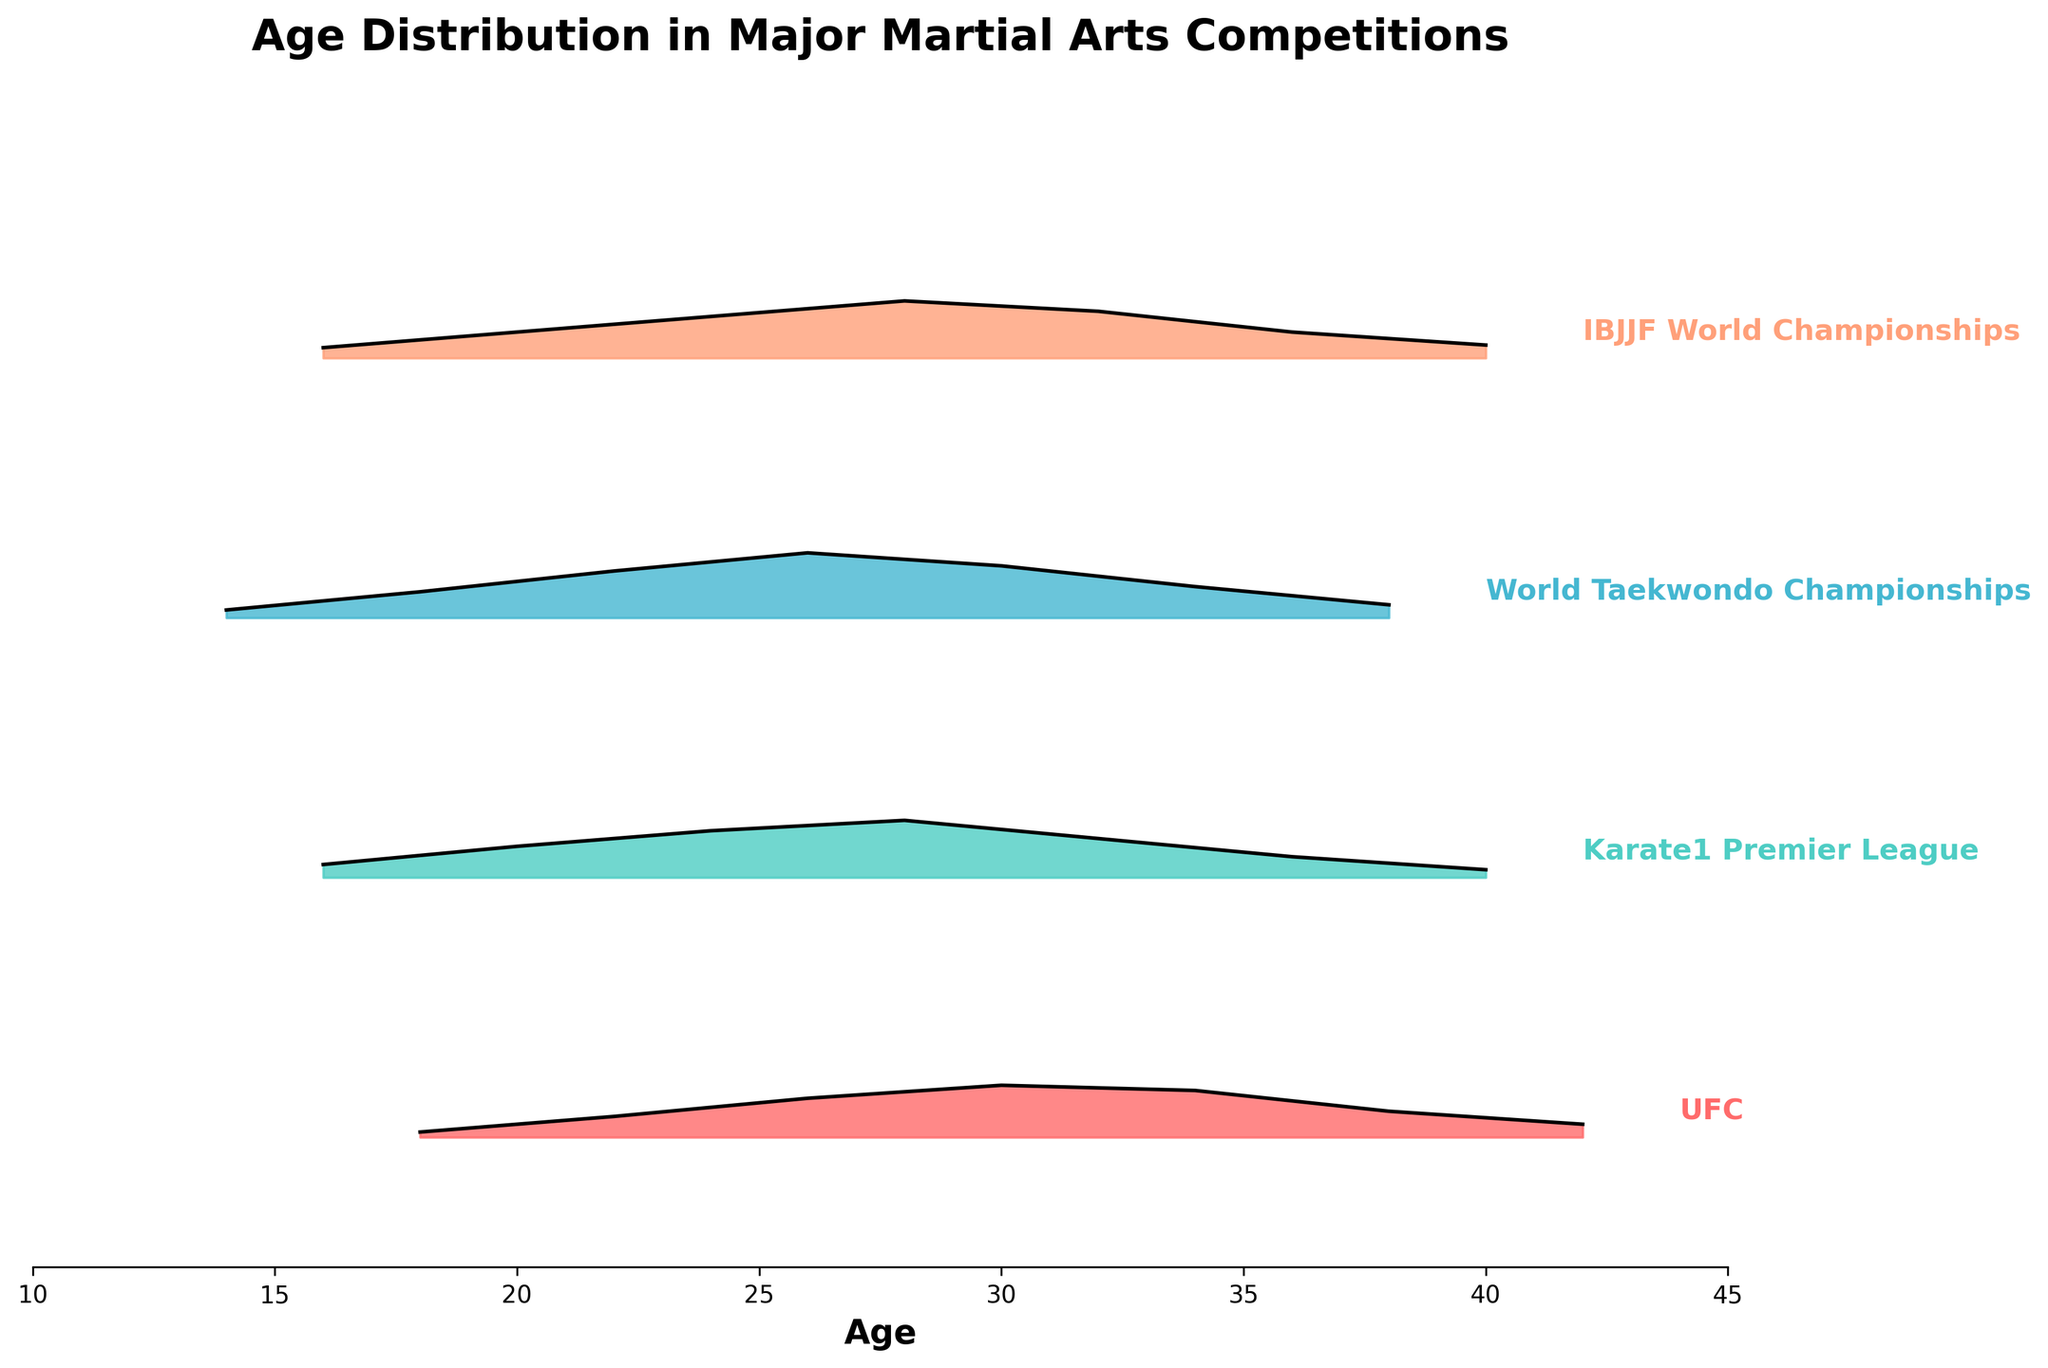What's the title of the figure? The title of a figure is usually found at the top and provides an overview of what the figure depicts.
Answer: Age Distribution in Major Martial Arts Competitions Which competition has the highest peak density in age distribution? The highest peak density for each competition can be found where the curve reaches its maximum height. By visually inspecting each competition's peak, we see World Taekwondo Championships with the highest.
Answer: World Taekwondo Championships At what age is the highest density observed for UFC participants? By looking at the density curve for UFC, the highest point on the curve is at age 30.
Answer: 30 Which competition has the widest age range of high density (densities greater than 0.1)? To determine the widest age range, find the age spans where the density is greater than 0.1 for each competition. For example, World Taekwondo Championships has high densities from ages 18 to 34. We compare this span to other competitions.
Answer: World Taekwondo Championships Compare the age distribution peaks between Karate1 Premier League and IBJJF World Championships; which has a higher peak and at what age? By observing the peak densities and their respective ages for both competitions, Karate1 Premier League's peak is at age 28 with density 0.22, and IBJJF World Championships' peak is also at age 28 with density 0.22. Both have the same peak.
Answer: Both have the same peak at age 28 and density 0.22 What's the average peak age across all competitions? Calculate the average of the ages where each competition has its highest density. For UFC: 30, Karate1 Premier League: 28, World Taekwondo Championships: 26, IBJJF World Championships: 28. The average is (30 + 28 + 26 + 28) / 4.
Answer: 28 Which competition has the lowest age at the peak density? Identify the lowest age where the density is at its peak for each competition. For World Taekwondo Championships, the peak is at age 26, which is lowest among the other competitions.
Answer: World Taekwondo Championships For which competition does the age density rise the fastest from the start? By analyzing the initial slope of the density curves for each competition starting from their lowest age, World Taekwondo Championships shows a rapid increase in density from age 14 to age 18.
Answer: World Taekwondo Championships What age ranges do not show any significant participant density (density values near 0) across all competitions? By examining the areas where all density curves are near 0, we observe that ages below 14 and above 42 (except World Taekwondo Championships starting at age 14) have negligible density.
Answer: Below 14 and above 42 